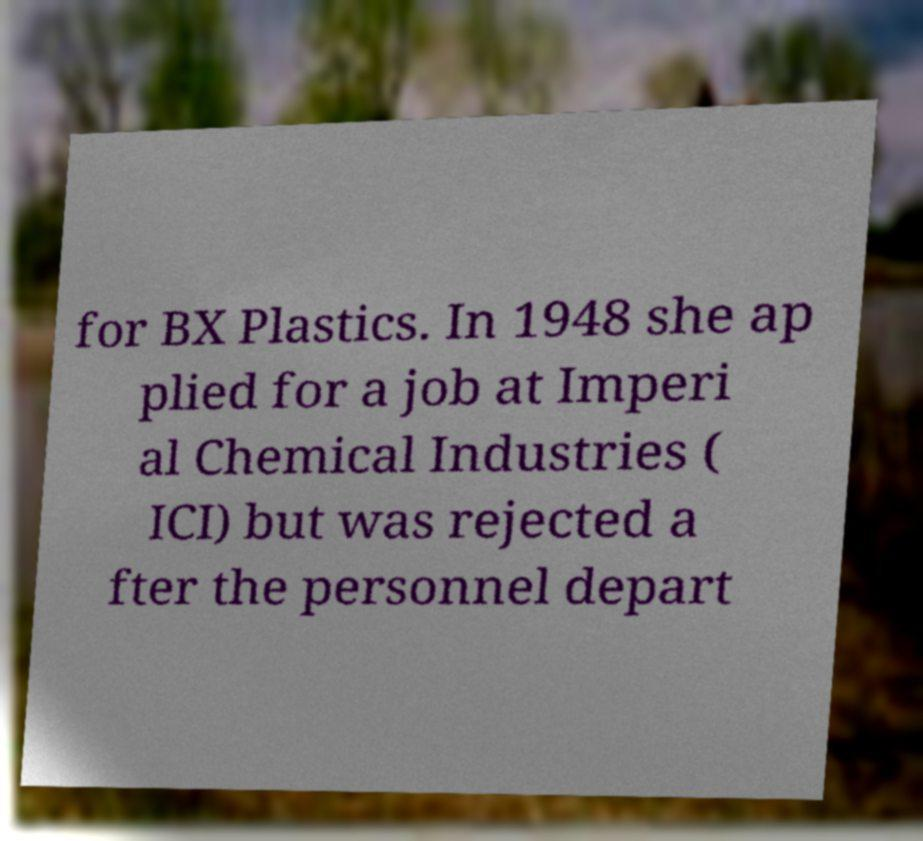I need the written content from this picture converted into text. Can you do that? for BX Plastics. In 1948 she ap plied for a job at Imperi al Chemical Industries ( ICI) but was rejected a fter the personnel depart 